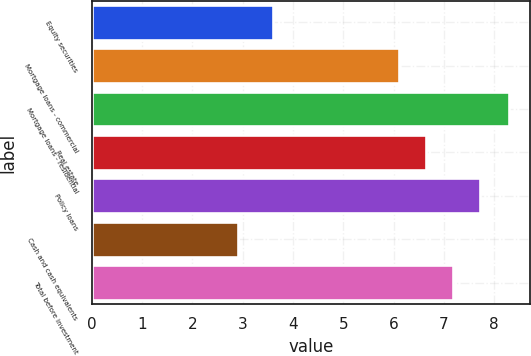Convert chart to OTSL. <chart><loc_0><loc_0><loc_500><loc_500><bar_chart><fcel>Equity securities<fcel>Mortgage loans - commercial<fcel>Mortgage loans - residential<fcel>Real estate<fcel>Policy loans<fcel>Cash and cash equivalents<fcel>Total before investment<nl><fcel>3.6<fcel>6.1<fcel>8.3<fcel>6.64<fcel>7.72<fcel>2.9<fcel>7.18<nl></chart> 